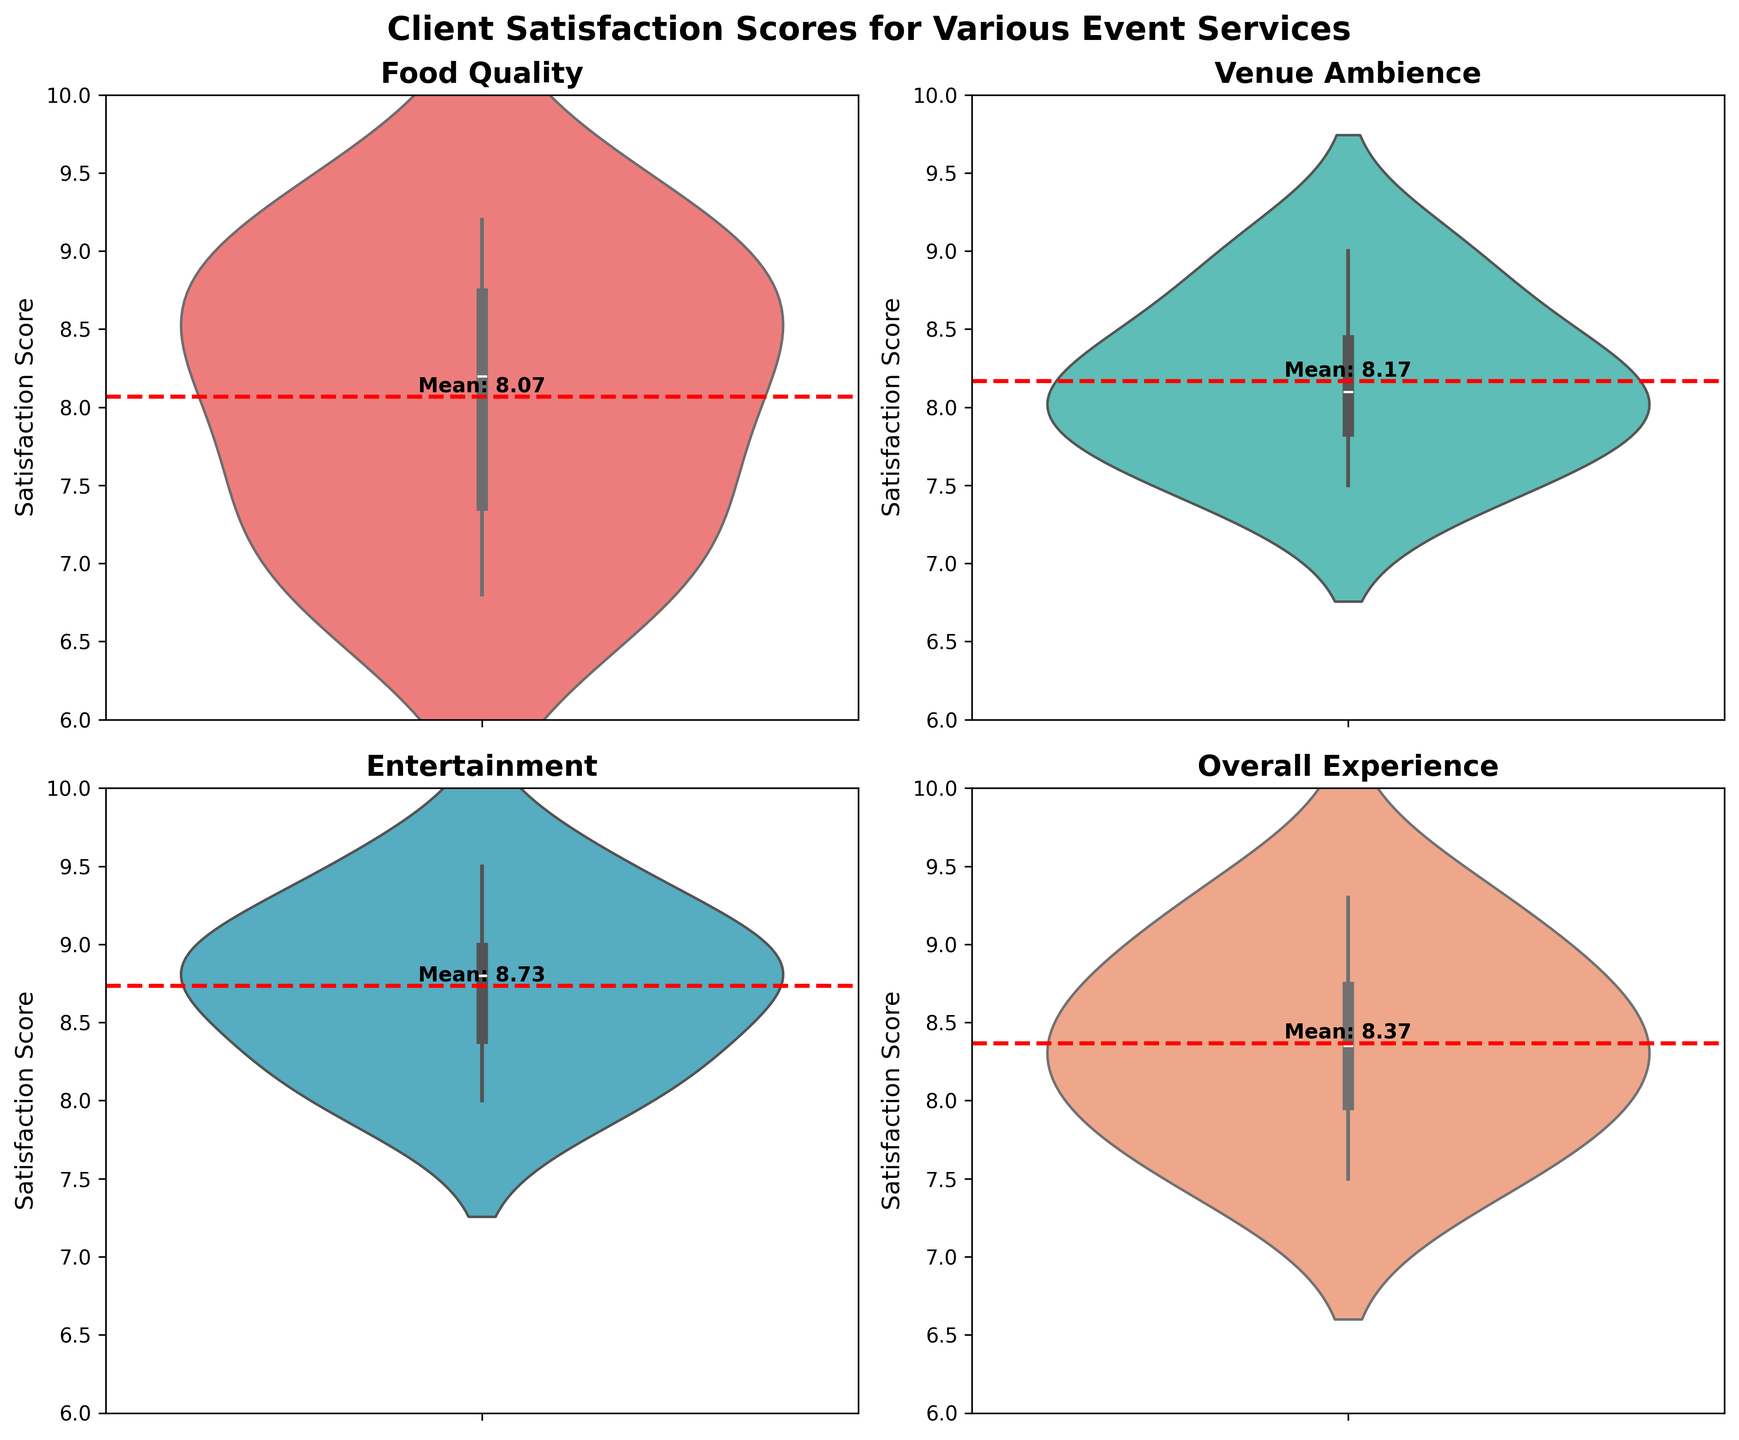What is the title of the figure? The title is the bold text at the top of the figure. It generally provides an overview of what the figure is about.
Answer: Client Satisfaction Scores for Various Event Services How many services are being evaluated in this figure? By looking at the different subplots and their titles, we can see the number of unique services being evaluated.
Answer: Four What is the color used for the "Food Quality" violin plot? Each service appears in a different color. By identifying the colors in the figure, we can discern which one corresponds to "Food Quality".
Answer: Red What is the mean satisfaction score for "Venue Ambience"? A horizontal line is drawn through each violin plot indicating the mean, and the exact value is labeled near the line.
Answer: 8.17 Which service has the highest mean satisfaction score? By comparing the mean lines and their values in each subplot, we can determine which service has the highest mean score.
Answer: Entertainment What is the range of satisfaction scores for "Overall Experience"? The range in a violin plot goes from the lowest value to the highest value where the plot starts and ends.
Answer: 7.5 to 9.3 How does the distribution of scores for "Entertainment" compare to "Food Quality"? We need to compare the shape, spread, and skewness of the violin plots for these two services.
Answer: "Entertainment" has a tighter distribution with higher scores, whereas "Food Quality" has a wider spread Which service has the most consistent satisfaction scores? The service with the least spread in its violin plot indicates the most consistent scores.
Answer: Entertainment Are there any services with outliers in the violin plots? We need to observe if any plot shows points that are clearly separate from the main body of the distribution. This figure has no outliers displayed.
Answer: No 